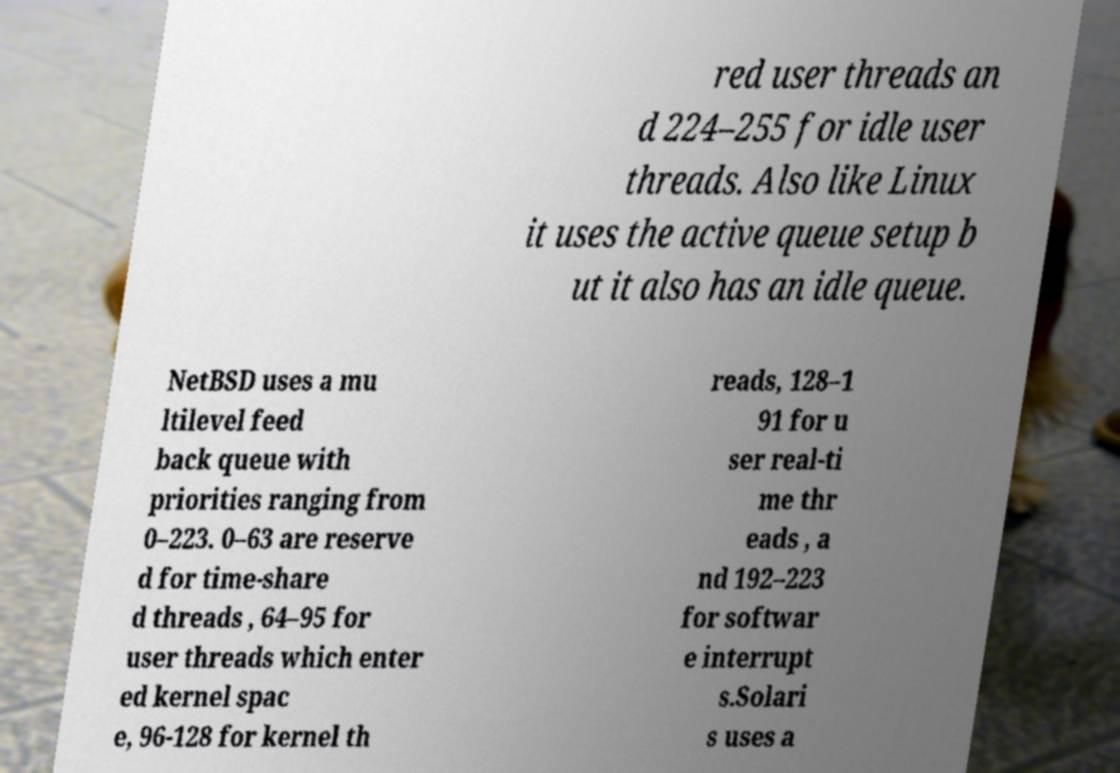I need the written content from this picture converted into text. Can you do that? red user threads an d 224–255 for idle user threads. Also like Linux it uses the active queue setup b ut it also has an idle queue. NetBSD uses a mu ltilevel feed back queue with priorities ranging from 0–223. 0–63 are reserve d for time-share d threads , 64–95 for user threads which enter ed kernel spac e, 96-128 for kernel th reads, 128–1 91 for u ser real-ti me thr eads , a nd 192–223 for softwar e interrupt s.Solari s uses a 